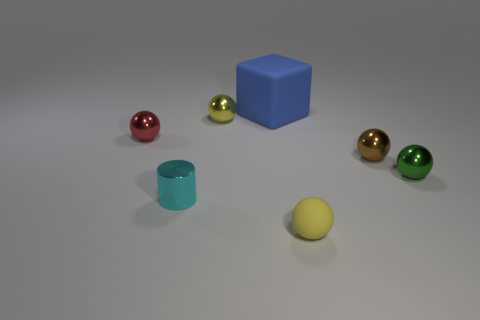There is a small green object that is the same material as the red thing; what shape is it?
Keep it short and to the point. Sphere. How big is the sphere in front of the tiny green ball?
Make the answer very short. Small. Is the number of rubber cubes on the right side of the tiny green sphere the same as the number of tiny green spheres on the right side of the small red ball?
Offer a very short reply. No. There is a tiny ball behind the tiny metal ball that is left of the yellow thing left of the yellow rubber object; what is its color?
Provide a succinct answer. Yellow. What number of things are both to the left of the yellow matte thing and right of the yellow metallic object?
Offer a terse response. 1. There is a sphere in front of the tiny cylinder; is it the same color as the tiny metal sphere that is behind the tiny red metal sphere?
Offer a very short reply. Yes. The rubber thing that is the same shape as the small brown metal object is what size?
Your answer should be very brief. Small. There is a green shiny object; are there any brown metal things in front of it?
Ensure brevity in your answer.  No. Is the number of small yellow matte balls to the left of the tiny matte ball the same as the number of tiny yellow metal cylinders?
Your answer should be very brief. Yes. There is a cube that is behind the small yellow object to the left of the small rubber sphere; is there a tiny brown ball that is to the right of it?
Your answer should be very brief. Yes. 